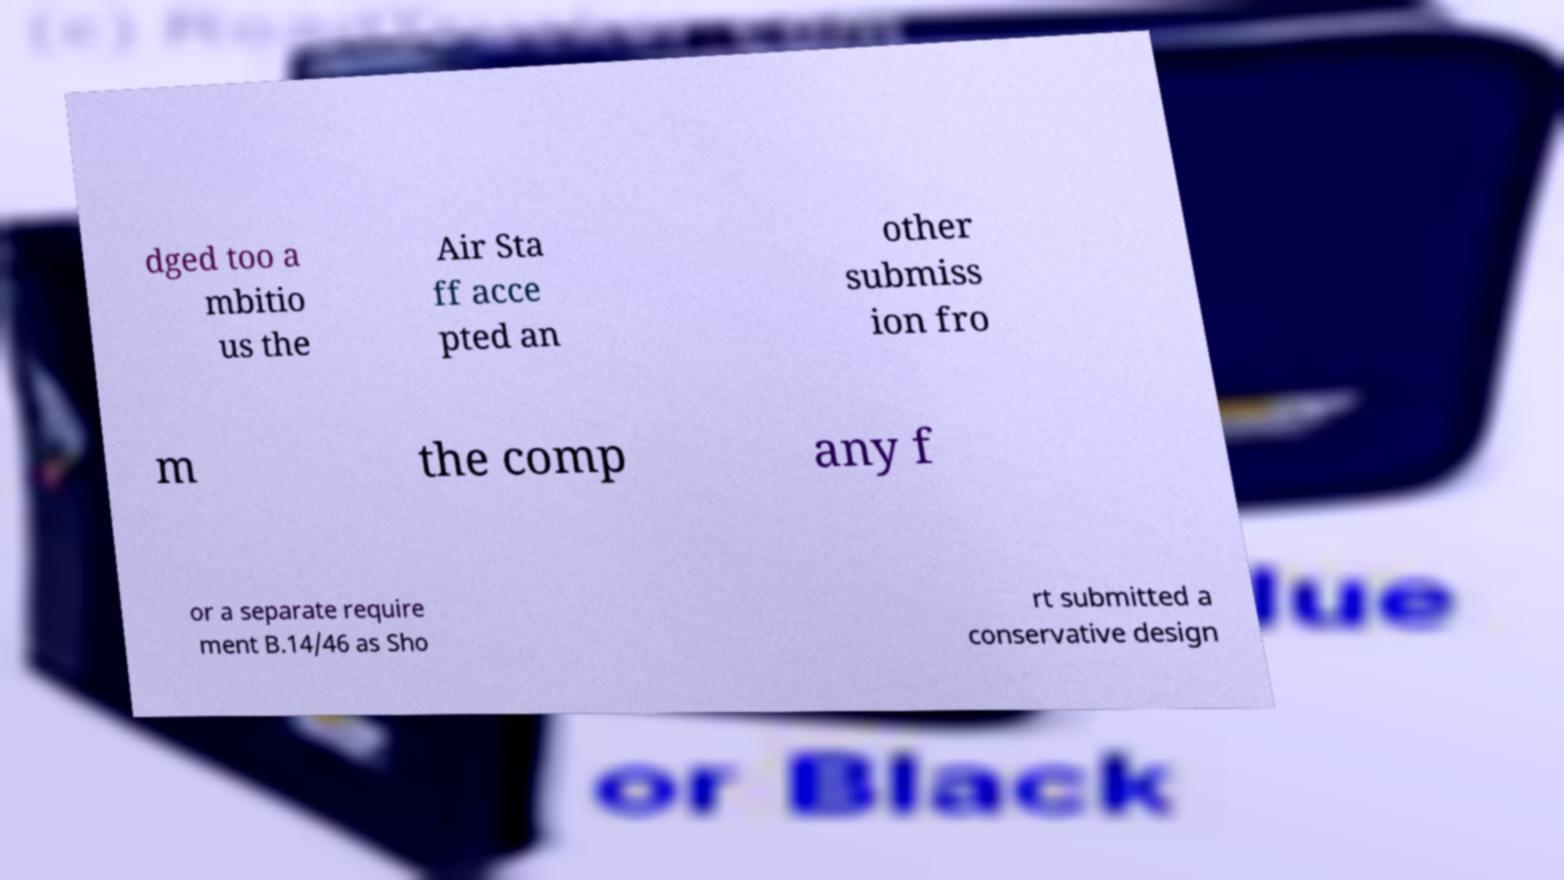Please identify and transcribe the text found in this image. dged too a mbitio us the Air Sta ff acce pted an other submiss ion fro m the comp any f or a separate require ment B.14/46 as Sho rt submitted a conservative design 